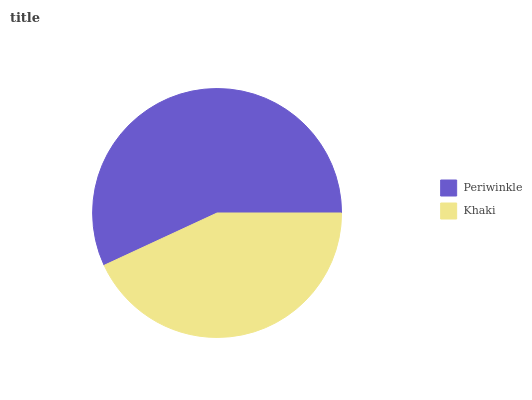Is Khaki the minimum?
Answer yes or no. Yes. Is Periwinkle the maximum?
Answer yes or no. Yes. Is Khaki the maximum?
Answer yes or no. No. Is Periwinkle greater than Khaki?
Answer yes or no. Yes. Is Khaki less than Periwinkle?
Answer yes or no. Yes. Is Khaki greater than Periwinkle?
Answer yes or no. No. Is Periwinkle less than Khaki?
Answer yes or no. No. Is Periwinkle the high median?
Answer yes or no. Yes. Is Khaki the low median?
Answer yes or no. Yes. Is Khaki the high median?
Answer yes or no. No. Is Periwinkle the low median?
Answer yes or no. No. 